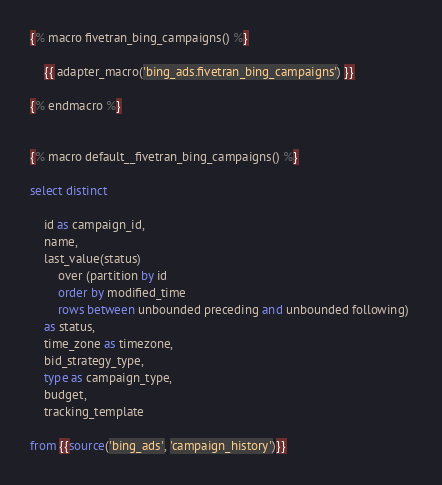<code> <loc_0><loc_0><loc_500><loc_500><_SQL_>{% macro fivetran_bing_campaigns() %}

    {{ adapter_macro('bing_ads.fivetran_bing_campaigns') }}

{% endmacro %}


{% macro default__fivetran_bing_campaigns() %}

select distinct

    id as campaign_id,
    name,
    last_value(status) 
        over (partition by id 
        order by modified_time 
        rows between unbounded preceding and unbounded following) 
    as status,
    time_zone as timezone,
    bid_strategy_type,
    type as campaign_type,
    budget,
    tracking_template

from {{source('bing_ads', 'campaign_history')}}</code> 